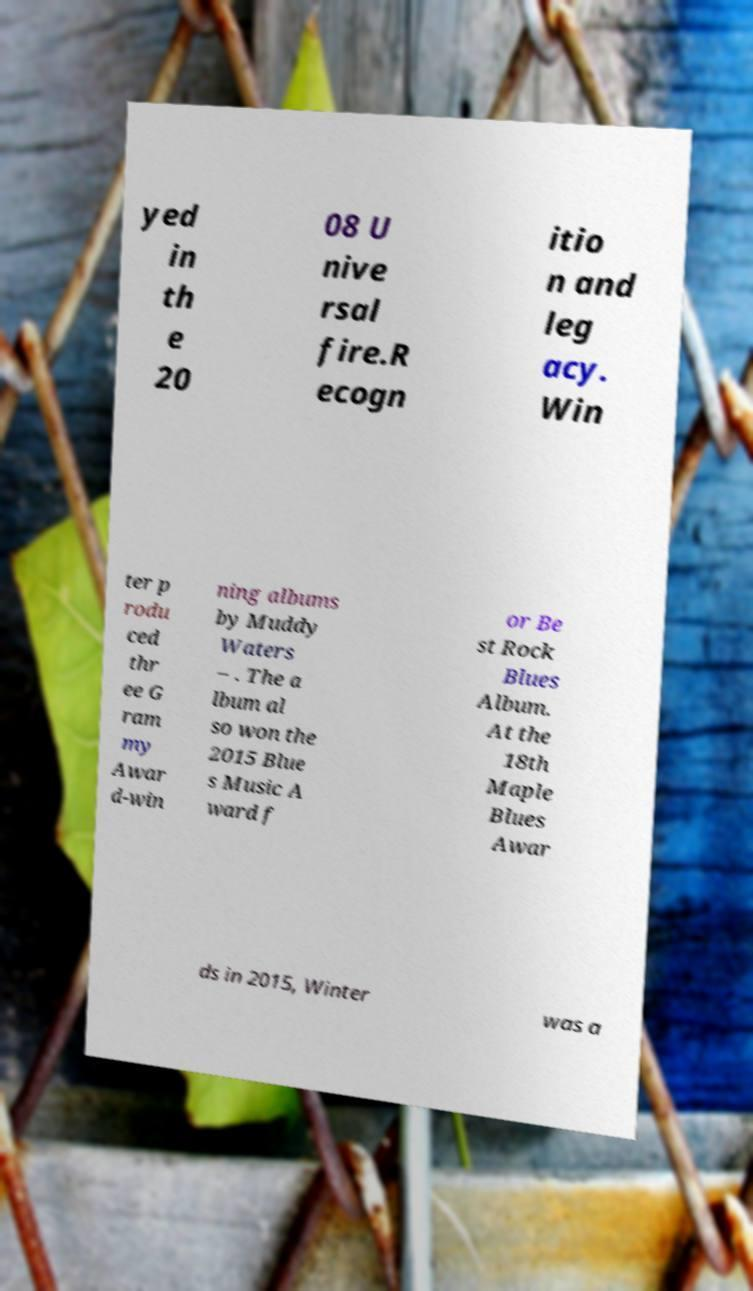Please identify and transcribe the text found in this image. yed in th e 20 08 U nive rsal fire.R ecogn itio n and leg acy. Win ter p rodu ced thr ee G ram my Awar d-win ning albums by Muddy Waters – . The a lbum al so won the 2015 Blue s Music A ward f or Be st Rock Blues Album. At the 18th Maple Blues Awar ds in 2015, Winter was a 